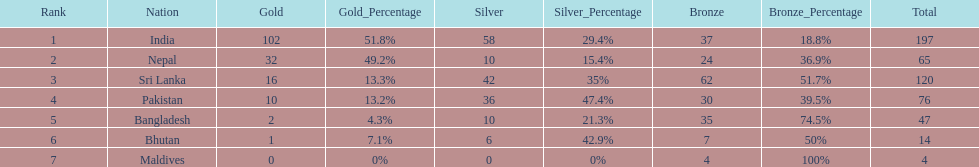What country has won no silver medals? Maldives. 